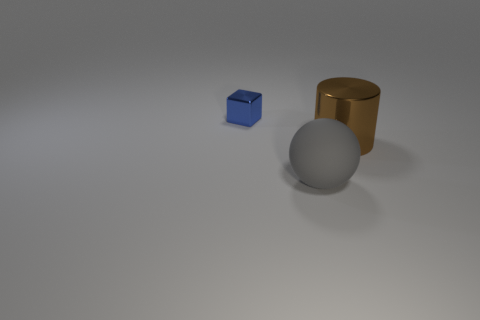There is a gray thing that is the same size as the brown cylinder; what shape is it?
Offer a very short reply. Sphere. How big is the brown metal cylinder?
Make the answer very short. Large. Is the size of the metallic thing in front of the cube the same as the metallic object that is left of the cylinder?
Your answer should be very brief. No. What color is the large thing to the left of the metal object on the right side of the small blue block?
Give a very brief answer. Gray. There is another thing that is the same size as the gray object; what material is it?
Provide a short and direct response. Metal. How many metallic things are either blocks or tiny gray spheres?
Make the answer very short. 1. There is a thing that is to the left of the brown shiny object and in front of the cube; what is its color?
Make the answer very short. Gray. There is a large brown thing; how many big brown metallic cylinders are on the right side of it?
Give a very brief answer. 0. What is the material of the block?
Make the answer very short. Metal. There is a shiny object right of the metal object on the left side of the metal object in front of the blue thing; what color is it?
Your answer should be compact. Brown. 